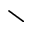<formula> <loc_0><loc_0><loc_500><loc_500>\</formula> 